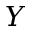Convert formula to latex. <formula><loc_0><loc_0><loc_500><loc_500>Y</formula> 